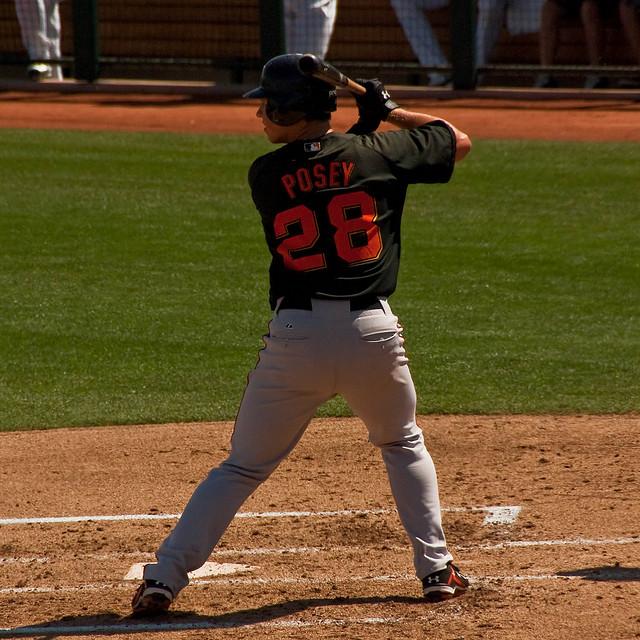What number is peavey?
Keep it brief. 28. Which leg does the batter have behind him?
Write a very short answer. Right. Is he a pro?
Quick response, please. Yes. Is he batting left handed?
Write a very short answer. No. What position does he play?
Answer briefly. Batter. What type of shoes are on his feet?
Answer briefly. Cleats. What is the name on his shirt?
Concise answer only. Posey. What is the number of the player?
Give a very brief answer. 28. What number does the Jersey say?
Short answer required. 28. What is the player's name?
Give a very brief answer. Posey. 